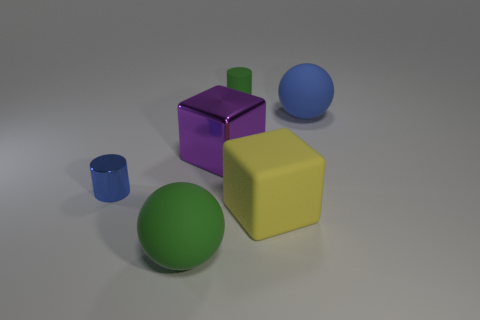What number of things are either red cylinders or big spheres?
Ensure brevity in your answer.  2. What number of rubber spheres have the same size as the blue matte thing?
Provide a short and direct response. 1. What shape is the big thing that is on the right side of the cube that is in front of the blue metallic object?
Make the answer very short. Sphere. Is the number of cyan shiny blocks less than the number of blue cylinders?
Your answer should be very brief. Yes. What color is the large sphere in front of the blue rubber ball?
Your answer should be very brief. Green. What material is the large object that is both on the right side of the small green thing and behind the blue metallic cylinder?
Provide a succinct answer. Rubber. The purple thing that is made of the same material as the blue cylinder is what shape?
Provide a succinct answer. Cube. What number of small cylinders are right of the large sphere left of the big blue rubber sphere?
Offer a very short reply. 1. What number of tiny objects are behind the big purple thing and in front of the big blue object?
Keep it short and to the point. 0. What number of other things are the same material as the large purple block?
Your answer should be very brief. 1. 